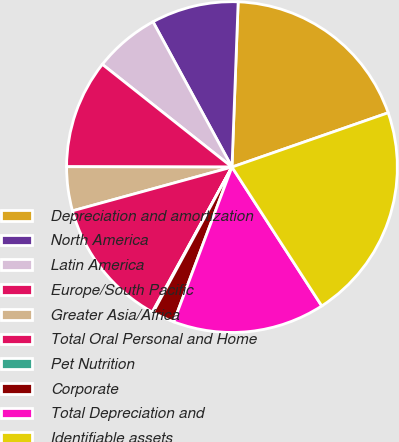<chart> <loc_0><loc_0><loc_500><loc_500><pie_chart><fcel>Depreciation and amortization<fcel>North America<fcel>Latin America<fcel>Europe/South Pacific<fcel>Greater Asia/Africa<fcel>Total Oral Personal and Home<fcel>Pet Nutrition<fcel>Corporate<fcel>Total Depreciation and<fcel>Identifiable assets<nl><fcel>19.08%<fcel>8.52%<fcel>6.41%<fcel>10.63%<fcel>4.3%<fcel>12.74%<fcel>0.08%<fcel>2.19%<fcel>14.86%<fcel>21.19%<nl></chart> 